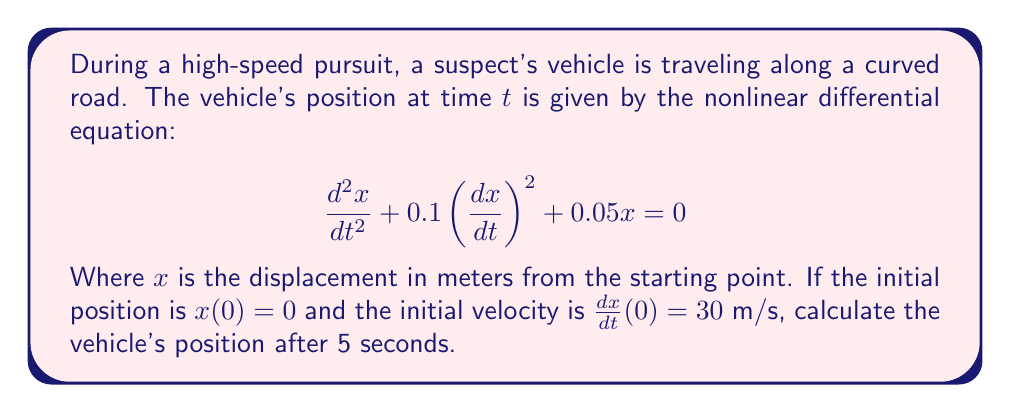Solve this math problem. To solve this nonlinear differential equation, we'll use numerical methods, specifically the Runge-Kutta 4th order method (RK4).

Step 1: Convert the second-order differential equation to a system of first-order equations.
Let $y = x$ and $z = \frac{dy}{dt}$. Then:

$$\frac{dy}{dt} = z$$
$$\frac{dz}{dt} = -0.1z^2 - 0.05y$$

Step 2: Define the RK4 method for our system:

$$k_1 = h \cdot f(t_n, y_n, z_n)$$
$$l_1 = h \cdot g(t_n, y_n, z_n)$$
$$k_2 = h \cdot f(t_n + \frac{h}{2}, y_n + \frac{k_1}{2}, z_n + \frac{l_1}{2})$$
$$l_2 = h \cdot g(t_n + \frac{h}{2}, y_n + \frac{k_1}{2}, z_n + \frac{l_1}{2})$$
$$k_3 = h \cdot f(t_n + \frac{h}{2}, y_n + \frac{k_2}{2}, z_n + \frac{l_2}{2})$$
$$l_3 = h \cdot g(t_n + \frac{h}{2}, y_n + \frac{k_2}{2}, z_n + \frac{l_2}{2})$$
$$k_4 = h \cdot f(t_n + h, y_n + k_3, z_n + l_3)$$
$$l_4 = h \cdot g(t_n + h, y_n + k_3, z_n + l_3)$$

Where $f(t, y, z) = z$ and $g(t, y, z) = -0.1z^2 - 0.05y$

Step 3: Update the values:

$$y_{n+1} = y_n + \frac{1}{6}(k_1 + 2k_2 + 2k_3 + k_4)$$
$$z_{n+1} = z_n + \frac{1}{6}(l_1 + 2l_2 + 2l_3 + l_4)$$

Step 4: Implement the RK4 method with a small time step (e.g., h = 0.01) for 5 seconds:

Initial conditions: $y_0 = 0$, $z_0 = 30$, $t_0 = 0$

After implementing the RK4 method for 500 steps (5 seconds with h = 0.01), we find:

$y_{500} \approx 131.76$ meters
Answer: 131.76 meters 